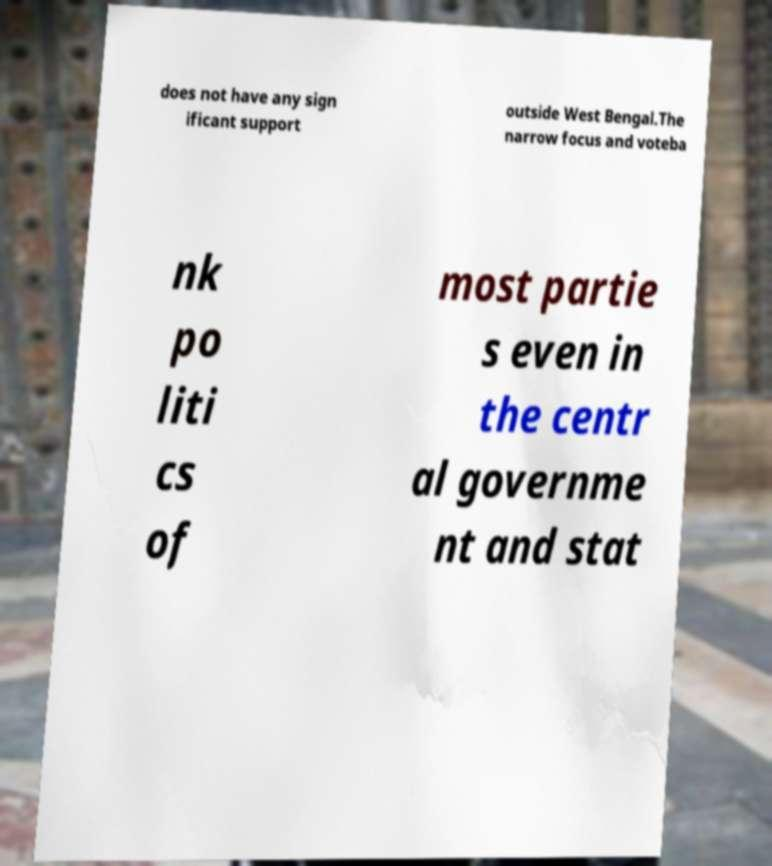Can you read and provide the text displayed in the image?This photo seems to have some interesting text. Can you extract and type it out for me? does not have any sign ificant support outside West Bengal.The narrow focus and voteba nk po liti cs of most partie s even in the centr al governme nt and stat 